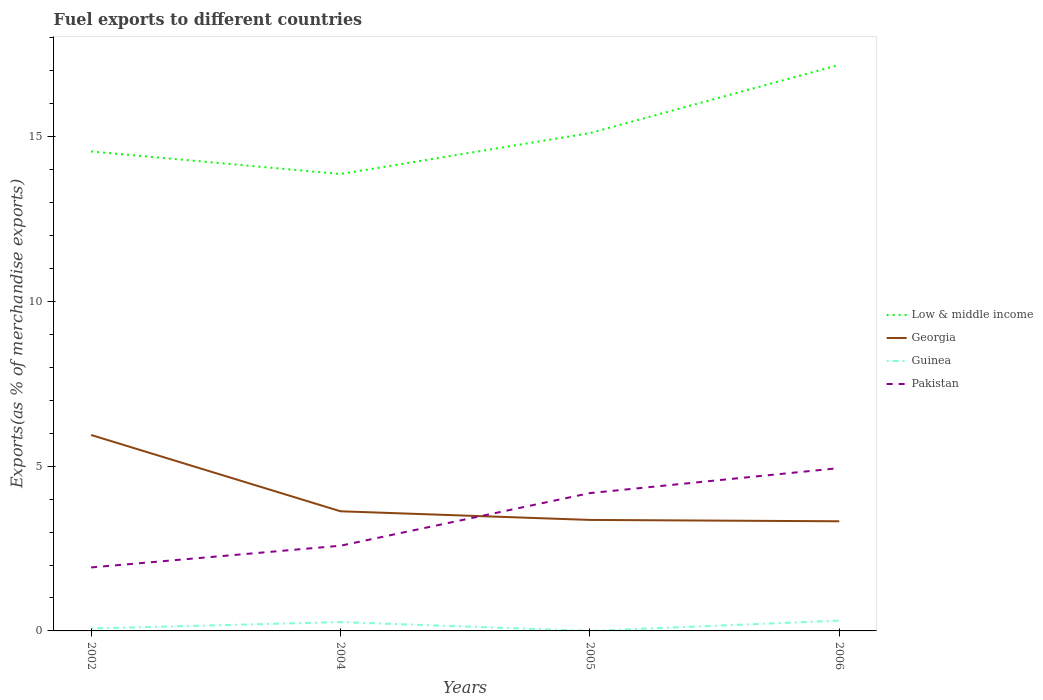How many different coloured lines are there?
Your answer should be very brief. 4. Does the line corresponding to Georgia intersect with the line corresponding to Pakistan?
Keep it short and to the point. Yes. Is the number of lines equal to the number of legend labels?
Your answer should be very brief. Yes. Across all years, what is the maximum percentage of exports to different countries in Low & middle income?
Make the answer very short. 13.86. What is the total percentage of exports to different countries in Georgia in the graph?
Your response must be concise. 2.58. What is the difference between the highest and the second highest percentage of exports to different countries in Georgia?
Ensure brevity in your answer.  2.62. What is the difference between the highest and the lowest percentage of exports to different countries in Guinea?
Offer a terse response. 2. Is the percentage of exports to different countries in Pakistan strictly greater than the percentage of exports to different countries in Guinea over the years?
Your answer should be compact. No. What is the difference between two consecutive major ticks on the Y-axis?
Offer a terse response. 5. Does the graph contain any zero values?
Offer a terse response. No. Does the graph contain grids?
Provide a succinct answer. No. How many legend labels are there?
Make the answer very short. 4. How are the legend labels stacked?
Your answer should be compact. Vertical. What is the title of the graph?
Your response must be concise. Fuel exports to different countries. What is the label or title of the Y-axis?
Your answer should be very brief. Exports(as % of merchandise exports). What is the Exports(as % of merchandise exports) in Low & middle income in 2002?
Ensure brevity in your answer.  14.55. What is the Exports(as % of merchandise exports) of Georgia in 2002?
Provide a succinct answer. 5.95. What is the Exports(as % of merchandise exports) in Guinea in 2002?
Provide a short and direct response. 0.07. What is the Exports(as % of merchandise exports) in Pakistan in 2002?
Provide a short and direct response. 1.93. What is the Exports(as % of merchandise exports) in Low & middle income in 2004?
Ensure brevity in your answer.  13.86. What is the Exports(as % of merchandise exports) in Georgia in 2004?
Your answer should be very brief. 3.63. What is the Exports(as % of merchandise exports) of Guinea in 2004?
Offer a terse response. 0.27. What is the Exports(as % of merchandise exports) of Pakistan in 2004?
Your answer should be very brief. 2.59. What is the Exports(as % of merchandise exports) in Low & middle income in 2005?
Make the answer very short. 15.11. What is the Exports(as % of merchandise exports) in Georgia in 2005?
Your answer should be compact. 3.37. What is the Exports(as % of merchandise exports) in Guinea in 2005?
Your answer should be compact. 3.9069582544466e-5. What is the Exports(as % of merchandise exports) in Pakistan in 2005?
Your answer should be compact. 4.18. What is the Exports(as % of merchandise exports) in Low & middle income in 2006?
Offer a terse response. 17.18. What is the Exports(as % of merchandise exports) in Georgia in 2006?
Ensure brevity in your answer.  3.33. What is the Exports(as % of merchandise exports) in Guinea in 2006?
Ensure brevity in your answer.  0.31. What is the Exports(as % of merchandise exports) of Pakistan in 2006?
Offer a terse response. 4.94. Across all years, what is the maximum Exports(as % of merchandise exports) of Low & middle income?
Provide a short and direct response. 17.18. Across all years, what is the maximum Exports(as % of merchandise exports) of Georgia?
Provide a short and direct response. 5.95. Across all years, what is the maximum Exports(as % of merchandise exports) of Guinea?
Your response must be concise. 0.31. Across all years, what is the maximum Exports(as % of merchandise exports) of Pakistan?
Offer a very short reply. 4.94. Across all years, what is the minimum Exports(as % of merchandise exports) in Low & middle income?
Offer a very short reply. 13.86. Across all years, what is the minimum Exports(as % of merchandise exports) of Georgia?
Your answer should be very brief. 3.33. Across all years, what is the minimum Exports(as % of merchandise exports) of Guinea?
Offer a terse response. 3.9069582544466e-5. Across all years, what is the minimum Exports(as % of merchandise exports) in Pakistan?
Offer a terse response. 1.93. What is the total Exports(as % of merchandise exports) in Low & middle income in the graph?
Give a very brief answer. 60.7. What is the total Exports(as % of merchandise exports) in Georgia in the graph?
Offer a very short reply. 16.27. What is the total Exports(as % of merchandise exports) of Guinea in the graph?
Provide a succinct answer. 0.65. What is the total Exports(as % of merchandise exports) of Pakistan in the graph?
Your answer should be very brief. 13.64. What is the difference between the Exports(as % of merchandise exports) of Low & middle income in 2002 and that in 2004?
Your answer should be compact. 0.68. What is the difference between the Exports(as % of merchandise exports) in Georgia in 2002 and that in 2004?
Offer a terse response. 2.31. What is the difference between the Exports(as % of merchandise exports) of Guinea in 2002 and that in 2004?
Ensure brevity in your answer.  -0.19. What is the difference between the Exports(as % of merchandise exports) in Pakistan in 2002 and that in 2004?
Your response must be concise. -0.66. What is the difference between the Exports(as % of merchandise exports) in Low & middle income in 2002 and that in 2005?
Provide a short and direct response. -0.56. What is the difference between the Exports(as % of merchandise exports) of Georgia in 2002 and that in 2005?
Offer a terse response. 2.58. What is the difference between the Exports(as % of merchandise exports) in Guinea in 2002 and that in 2005?
Give a very brief answer. 0.07. What is the difference between the Exports(as % of merchandise exports) in Pakistan in 2002 and that in 2005?
Your answer should be very brief. -2.26. What is the difference between the Exports(as % of merchandise exports) in Low & middle income in 2002 and that in 2006?
Provide a short and direct response. -2.63. What is the difference between the Exports(as % of merchandise exports) in Georgia in 2002 and that in 2006?
Provide a succinct answer. 2.62. What is the difference between the Exports(as % of merchandise exports) in Guinea in 2002 and that in 2006?
Provide a short and direct response. -0.24. What is the difference between the Exports(as % of merchandise exports) in Pakistan in 2002 and that in 2006?
Provide a succinct answer. -3.01. What is the difference between the Exports(as % of merchandise exports) in Low & middle income in 2004 and that in 2005?
Provide a succinct answer. -1.24. What is the difference between the Exports(as % of merchandise exports) in Georgia in 2004 and that in 2005?
Provide a succinct answer. 0.26. What is the difference between the Exports(as % of merchandise exports) in Guinea in 2004 and that in 2005?
Provide a succinct answer. 0.27. What is the difference between the Exports(as % of merchandise exports) in Pakistan in 2004 and that in 2005?
Provide a succinct answer. -1.6. What is the difference between the Exports(as % of merchandise exports) of Low & middle income in 2004 and that in 2006?
Your answer should be very brief. -3.31. What is the difference between the Exports(as % of merchandise exports) in Georgia in 2004 and that in 2006?
Provide a succinct answer. 0.3. What is the difference between the Exports(as % of merchandise exports) of Guinea in 2004 and that in 2006?
Provide a succinct answer. -0.04. What is the difference between the Exports(as % of merchandise exports) of Pakistan in 2004 and that in 2006?
Make the answer very short. -2.36. What is the difference between the Exports(as % of merchandise exports) of Low & middle income in 2005 and that in 2006?
Provide a short and direct response. -2.07. What is the difference between the Exports(as % of merchandise exports) of Georgia in 2005 and that in 2006?
Provide a succinct answer. 0.04. What is the difference between the Exports(as % of merchandise exports) of Guinea in 2005 and that in 2006?
Provide a short and direct response. -0.31. What is the difference between the Exports(as % of merchandise exports) in Pakistan in 2005 and that in 2006?
Give a very brief answer. -0.76. What is the difference between the Exports(as % of merchandise exports) in Low & middle income in 2002 and the Exports(as % of merchandise exports) in Georgia in 2004?
Ensure brevity in your answer.  10.92. What is the difference between the Exports(as % of merchandise exports) of Low & middle income in 2002 and the Exports(as % of merchandise exports) of Guinea in 2004?
Keep it short and to the point. 14.28. What is the difference between the Exports(as % of merchandise exports) of Low & middle income in 2002 and the Exports(as % of merchandise exports) of Pakistan in 2004?
Offer a terse response. 11.96. What is the difference between the Exports(as % of merchandise exports) of Georgia in 2002 and the Exports(as % of merchandise exports) of Guinea in 2004?
Offer a terse response. 5.68. What is the difference between the Exports(as % of merchandise exports) of Georgia in 2002 and the Exports(as % of merchandise exports) of Pakistan in 2004?
Ensure brevity in your answer.  3.36. What is the difference between the Exports(as % of merchandise exports) in Guinea in 2002 and the Exports(as % of merchandise exports) in Pakistan in 2004?
Provide a short and direct response. -2.51. What is the difference between the Exports(as % of merchandise exports) in Low & middle income in 2002 and the Exports(as % of merchandise exports) in Georgia in 2005?
Your response must be concise. 11.18. What is the difference between the Exports(as % of merchandise exports) of Low & middle income in 2002 and the Exports(as % of merchandise exports) of Guinea in 2005?
Provide a succinct answer. 14.55. What is the difference between the Exports(as % of merchandise exports) in Low & middle income in 2002 and the Exports(as % of merchandise exports) in Pakistan in 2005?
Your answer should be very brief. 10.37. What is the difference between the Exports(as % of merchandise exports) of Georgia in 2002 and the Exports(as % of merchandise exports) of Guinea in 2005?
Your answer should be compact. 5.95. What is the difference between the Exports(as % of merchandise exports) in Georgia in 2002 and the Exports(as % of merchandise exports) in Pakistan in 2005?
Give a very brief answer. 1.76. What is the difference between the Exports(as % of merchandise exports) of Guinea in 2002 and the Exports(as % of merchandise exports) of Pakistan in 2005?
Make the answer very short. -4.11. What is the difference between the Exports(as % of merchandise exports) of Low & middle income in 2002 and the Exports(as % of merchandise exports) of Georgia in 2006?
Your answer should be compact. 11.22. What is the difference between the Exports(as % of merchandise exports) in Low & middle income in 2002 and the Exports(as % of merchandise exports) in Guinea in 2006?
Provide a succinct answer. 14.24. What is the difference between the Exports(as % of merchandise exports) of Low & middle income in 2002 and the Exports(as % of merchandise exports) of Pakistan in 2006?
Your response must be concise. 9.61. What is the difference between the Exports(as % of merchandise exports) in Georgia in 2002 and the Exports(as % of merchandise exports) in Guinea in 2006?
Provide a succinct answer. 5.63. What is the difference between the Exports(as % of merchandise exports) of Georgia in 2002 and the Exports(as % of merchandise exports) of Pakistan in 2006?
Your answer should be very brief. 1. What is the difference between the Exports(as % of merchandise exports) of Guinea in 2002 and the Exports(as % of merchandise exports) of Pakistan in 2006?
Offer a very short reply. -4.87. What is the difference between the Exports(as % of merchandise exports) of Low & middle income in 2004 and the Exports(as % of merchandise exports) of Georgia in 2005?
Give a very brief answer. 10.5. What is the difference between the Exports(as % of merchandise exports) of Low & middle income in 2004 and the Exports(as % of merchandise exports) of Guinea in 2005?
Offer a very short reply. 13.86. What is the difference between the Exports(as % of merchandise exports) in Low & middle income in 2004 and the Exports(as % of merchandise exports) in Pakistan in 2005?
Provide a succinct answer. 9.68. What is the difference between the Exports(as % of merchandise exports) in Georgia in 2004 and the Exports(as % of merchandise exports) in Guinea in 2005?
Give a very brief answer. 3.63. What is the difference between the Exports(as % of merchandise exports) of Georgia in 2004 and the Exports(as % of merchandise exports) of Pakistan in 2005?
Offer a very short reply. -0.55. What is the difference between the Exports(as % of merchandise exports) of Guinea in 2004 and the Exports(as % of merchandise exports) of Pakistan in 2005?
Provide a short and direct response. -3.91. What is the difference between the Exports(as % of merchandise exports) in Low & middle income in 2004 and the Exports(as % of merchandise exports) in Georgia in 2006?
Provide a short and direct response. 10.54. What is the difference between the Exports(as % of merchandise exports) of Low & middle income in 2004 and the Exports(as % of merchandise exports) of Guinea in 2006?
Offer a terse response. 13.55. What is the difference between the Exports(as % of merchandise exports) in Low & middle income in 2004 and the Exports(as % of merchandise exports) in Pakistan in 2006?
Give a very brief answer. 8.92. What is the difference between the Exports(as % of merchandise exports) of Georgia in 2004 and the Exports(as % of merchandise exports) of Guinea in 2006?
Offer a terse response. 3.32. What is the difference between the Exports(as % of merchandise exports) in Georgia in 2004 and the Exports(as % of merchandise exports) in Pakistan in 2006?
Your answer should be compact. -1.31. What is the difference between the Exports(as % of merchandise exports) of Guinea in 2004 and the Exports(as % of merchandise exports) of Pakistan in 2006?
Give a very brief answer. -4.67. What is the difference between the Exports(as % of merchandise exports) in Low & middle income in 2005 and the Exports(as % of merchandise exports) in Georgia in 2006?
Provide a succinct answer. 11.78. What is the difference between the Exports(as % of merchandise exports) in Low & middle income in 2005 and the Exports(as % of merchandise exports) in Guinea in 2006?
Offer a terse response. 14.79. What is the difference between the Exports(as % of merchandise exports) of Low & middle income in 2005 and the Exports(as % of merchandise exports) of Pakistan in 2006?
Give a very brief answer. 10.16. What is the difference between the Exports(as % of merchandise exports) in Georgia in 2005 and the Exports(as % of merchandise exports) in Guinea in 2006?
Offer a terse response. 3.06. What is the difference between the Exports(as % of merchandise exports) in Georgia in 2005 and the Exports(as % of merchandise exports) in Pakistan in 2006?
Offer a terse response. -1.57. What is the difference between the Exports(as % of merchandise exports) of Guinea in 2005 and the Exports(as % of merchandise exports) of Pakistan in 2006?
Offer a terse response. -4.94. What is the average Exports(as % of merchandise exports) of Low & middle income per year?
Your answer should be very brief. 15.17. What is the average Exports(as % of merchandise exports) of Georgia per year?
Ensure brevity in your answer.  4.07. What is the average Exports(as % of merchandise exports) of Guinea per year?
Provide a succinct answer. 0.16. What is the average Exports(as % of merchandise exports) in Pakistan per year?
Your response must be concise. 3.41. In the year 2002, what is the difference between the Exports(as % of merchandise exports) of Low & middle income and Exports(as % of merchandise exports) of Georgia?
Provide a succinct answer. 8.6. In the year 2002, what is the difference between the Exports(as % of merchandise exports) of Low & middle income and Exports(as % of merchandise exports) of Guinea?
Provide a succinct answer. 14.48. In the year 2002, what is the difference between the Exports(as % of merchandise exports) of Low & middle income and Exports(as % of merchandise exports) of Pakistan?
Provide a short and direct response. 12.62. In the year 2002, what is the difference between the Exports(as % of merchandise exports) in Georgia and Exports(as % of merchandise exports) in Guinea?
Provide a succinct answer. 5.87. In the year 2002, what is the difference between the Exports(as % of merchandise exports) in Georgia and Exports(as % of merchandise exports) in Pakistan?
Ensure brevity in your answer.  4.02. In the year 2002, what is the difference between the Exports(as % of merchandise exports) in Guinea and Exports(as % of merchandise exports) in Pakistan?
Give a very brief answer. -1.85. In the year 2004, what is the difference between the Exports(as % of merchandise exports) in Low & middle income and Exports(as % of merchandise exports) in Georgia?
Provide a short and direct response. 10.23. In the year 2004, what is the difference between the Exports(as % of merchandise exports) of Low & middle income and Exports(as % of merchandise exports) of Guinea?
Offer a very short reply. 13.6. In the year 2004, what is the difference between the Exports(as % of merchandise exports) of Low & middle income and Exports(as % of merchandise exports) of Pakistan?
Your response must be concise. 11.28. In the year 2004, what is the difference between the Exports(as % of merchandise exports) of Georgia and Exports(as % of merchandise exports) of Guinea?
Your response must be concise. 3.36. In the year 2004, what is the difference between the Exports(as % of merchandise exports) in Georgia and Exports(as % of merchandise exports) in Pakistan?
Ensure brevity in your answer.  1.05. In the year 2004, what is the difference between the Exports(as % of merchandise exports) of Guinea and Exports(as % of merchandise exports) of Pakistan?
Provide a succinct answer. -2.32. In the year 2005, what is the difference between the Exports(as % of merchandise exports) in Low & middle income and Exports(as % of merchandise exports) in Georgia?
Your response must be concise. 11.74. In the year 2005, what is the difference between the Exports(as % of merchandise exports) of Low & middle income and Exports(as % of merchandise exports) of Guinea?
Offer a terse response. 15.11. In the year 2005, what is the difference between the Exports(as % of merchandise exports) of Low & middle income and Exports(as % of merchandise exports) of Pakistan?
Keep it short and to the point. 10.92. In the year 2005, what is the difference between the Exports(as % of merchandise exports) of Georgia and Exports(as % of merchandise exports) of Guinea?
Offer a very short reply. 3.37. In the year 2005, what is the difference between the Exports(as % of merchandise exports) of Georgia and Exports(as % of merchandise exports) of Pakistan?
Provide a short and direct response. -0.81. In the year 2005, what is the difference between the Exports(as % of merchandise exports) in Guinea and Exports(as % of merchandise exports) in Pakistan?
Ensure brevity in your answer.  -4.18. In the year 2006, what is the difference between the Exports(as % of merchandise exports) in Low & middle income and Exports(as % of merchandise exports) in Georgia?
Keep it short and to the point. 13.85. In the year 2006, what is the difference between the Exports(as % of merchandise exports) in Low & middle income and Exports(as % of merchandise exports) in Guinea?
Offer a very short reply. 16.86. In the year 2006, what is the difference between the Exports(as % of merchandise exports) in Low & middle income and Exports(as % of merchandise exports) in Pakistan?
Your answer should be compact. 12.24. In the year 2006, what is the difference between the Exports(as % of merchandise exports) of Georgia and Exports(as % of merchandise exports) of Guinea?
Offer a very short reply. 3.01. In the year 2006, what is the difference between the Exports(as % of merchandise exports) in Georgia and Exports(as % of merchandise exports) in Pakistan?
Make the answer very short. -1.61. In the year 2006, what is the difference between the Exports(as % of merchandise exports) of Guinea and Exports(as % of merchandise exports) of Pakistan?
Your answer should be very brief. -4.63. What is the ratio of the Exports(as % of merchandise exports) in Low & middle income in 2002 to that in 2004?
Your answer should be very brief. 1.05. What is the ratio of the Exports(as % of merchandise exports) of Georgia in 2002 to that in 2004?
Your answer should be very brief. 1.64. What is the ratio of the Exports(as % of merchandise exports) in Guinea in 2002 to that in 2004?
Offer a terse response. 0.27. What is the ratio of the Exports(as % of merchandise exports) of Pakistan in 2002 to that in 2004?
Ensure brevity in your answer.  0.75. What is the ratio of the Exports(as % of merchandise exports) of Low & middle income in 2002 to that in 2005?
Make the answer very short. 0.96. What is the ratio of the Exports(as % of merchandise exports) of Georgia in 2002 to that in 2005?
Your answer should be very brief. 1.77. What is the ratio of the Exports(as % of merchandise exports) of Guinea in 2002 to that in 2005?
Offer a very short reply. 1887.48. What is the ratio of the Exports(as % of merchandise exports) in Pakistan in 2002 to that in 2005?
Ensure brevity in your answer.  0.46. What is the ratio of the Exports(as % of merchandise exports) of Low & middle income in 2002 to that in 2006?
Keep it short and to the point. 0.85. What is the ratio of the Exports(as % of merchandise exports) of Georgia in 2002 to that in 2006?
Offer a very short reply. 1.79. What is the ratio of the Exports(as % of merchandise exports) in Guinea in 2002 to that in 2006?
Offer a terse response. 0.24. What is the ratio of the Exports(as % of merchandise exports) in Pakistan in 2002 to that in 2006?
Make the answer very short. 0.39. What is the ratio of the Exports(as % of merchandise exports) of Low & middle income in 2004 to that in 2005?
Your answer should be very brief. 0.92. What is the ratio of the Exports(as % of merchandise exports) of Georgia in 2004 to that in 2005?
Keep it short and to the point. 1.08. What is the ratio of the Exports(as % of merchandise exports) in Guinea in 2004 to that in 2005?
Provide a succinct answer. 6866.83. What is the ratio of the Exports(as % of merchandise exports) in Pakistan in 2004 to that in 2005?
Keep it short and to the point. 0.62. What is the ratio of the Exports(as % of merchandise exports) in Low & middle income in 2004 to that in 2006?
Your response must be concise. 0.81. What is the ratio of the Exports(as % of merchandise exports) in Georgia in 2004 to that in 2006?
Give a very brief answer. 1.09. What is the ratio of the Exports(as % of merchandise exports) in Guinea in 2004 to that in 2006?
Ensure brevity in your answer.  0.86. What is the ratio of the Exports(as % of merchandise exports) of Pakistan in 2004 to that in 2006?
Ensure brevity in your answer.  0.52. What is the ratio of the Exports(as % of merchandise exports) in Low & middle income in 2005 to that in 2006?
Provide a short and direct response. 0.88. What is the ratio of the Exports(as % of merchandise exports) in Georgia in 2005 to that in 2006?
Ensure brevity in your answer.  1.01. What is the ratio of the Exports(as % of merchandise exports) in Guinea in 2005 to that in 2006?
Offer a very short reply. 0. What is the ratio of the Exports(as % of merchandise exports) in Pakistan in 2005 to that in 2006?
Your response must be concise. 0.85. What is the difference between the highest and the second highest Exports(as % of merchandise exports) in Low & middle income?
Your answer should be compact. 2.07. What is the difference between the highest and the second highest Exports(as % of merchandise exports) in Georgia?
Offer a very short reply. 2.31. What is the difference between the highest and the second highest Exports(as % of merchandise exports) in Guinea?
Your answer should be very brief. 0.04. What is the difference between the highest and the second highest Exports(as % of merchandise exports) in Pakistan?
Your answer should be compact. 0.76. What is the difference between the highest and the lowest Exports(as % of merchandise exports) of Low & middle income?
Your response must be concise. 3.31. What is the difference between the highest and the lowest Exports(as % of merchandise exports) in Georgia?
Your answer should be very brief. 2.62. What is the difference between the highest and the lowest Exports(as % of merchandise exports) of Guinea?
Provide a succinct answer. 0.31. What is the difference between the highest and the lowest Exports(as % of merchandise exports) of Pakistan?
Your answer should be compact. 3.01. 